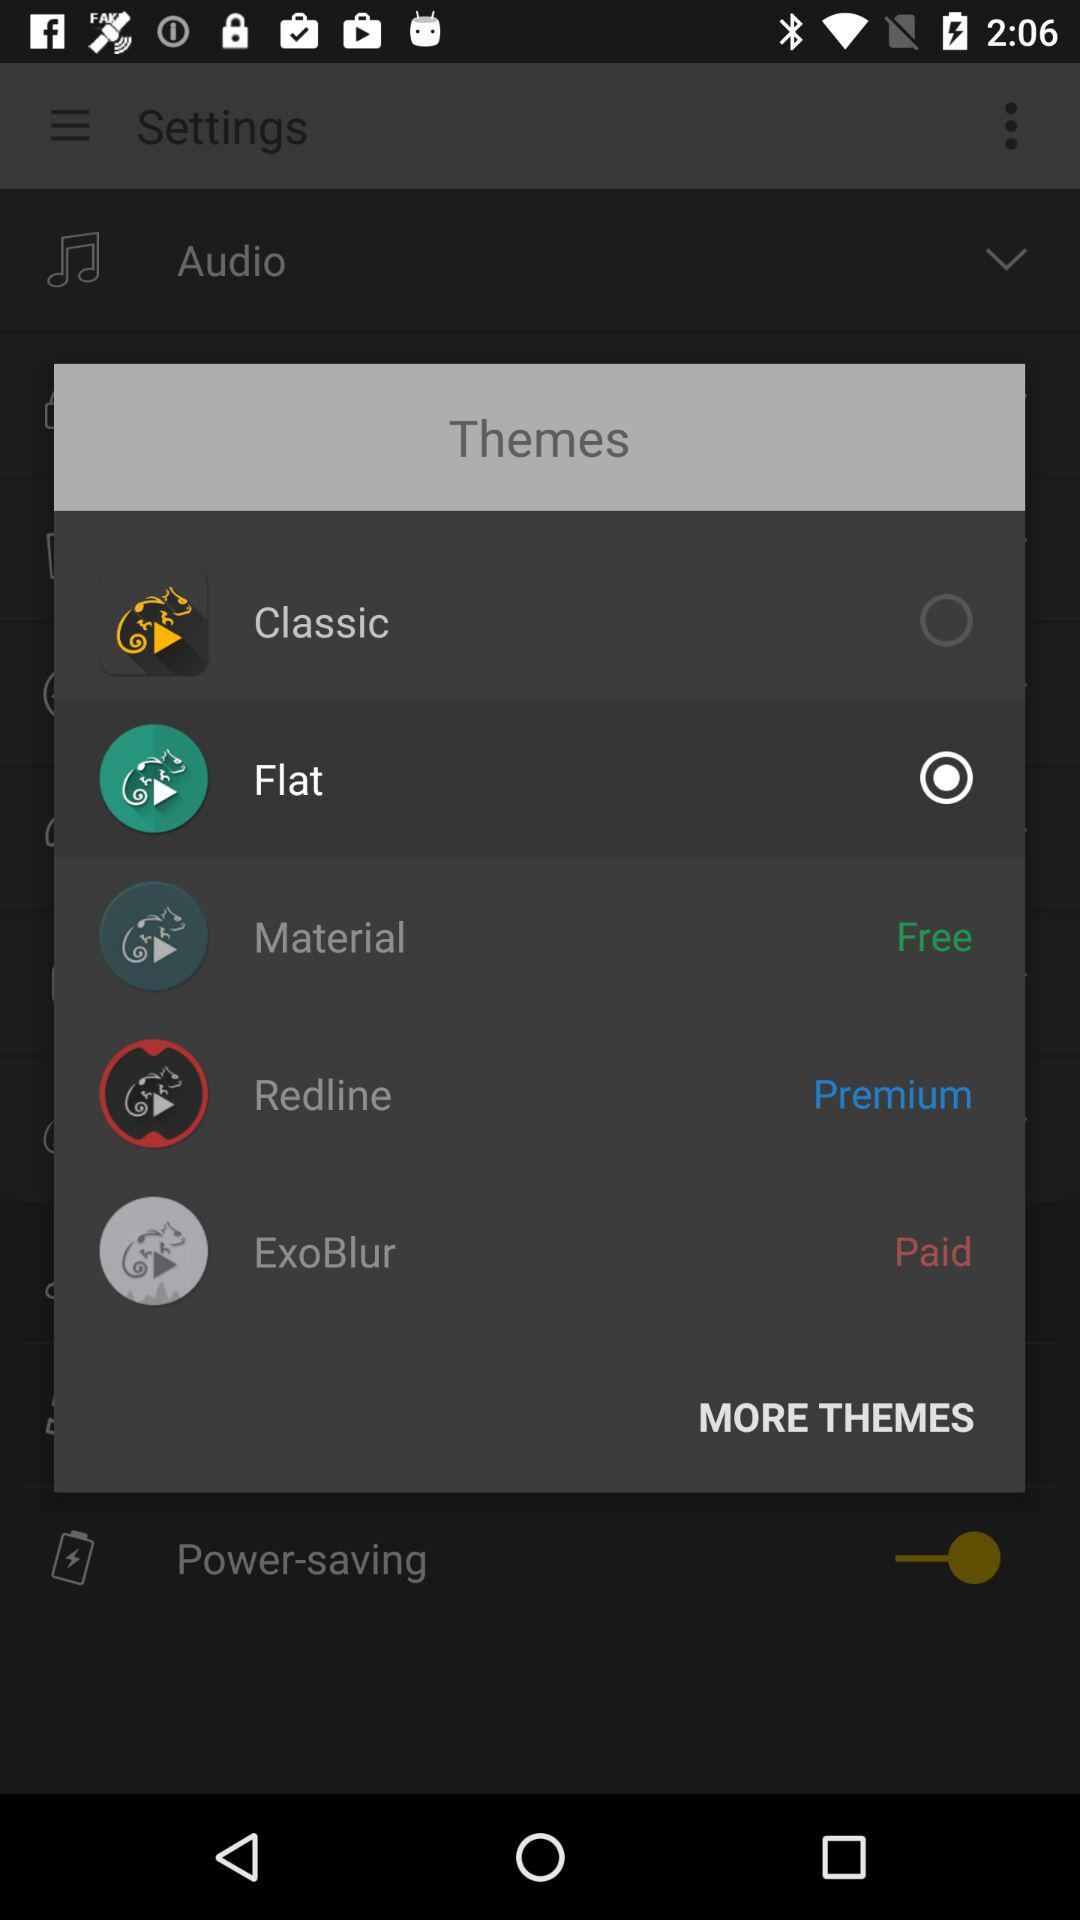What are the different themes available? The themes are "Classic", "Flat", "Material", "Redline" and "ExoBlur". 